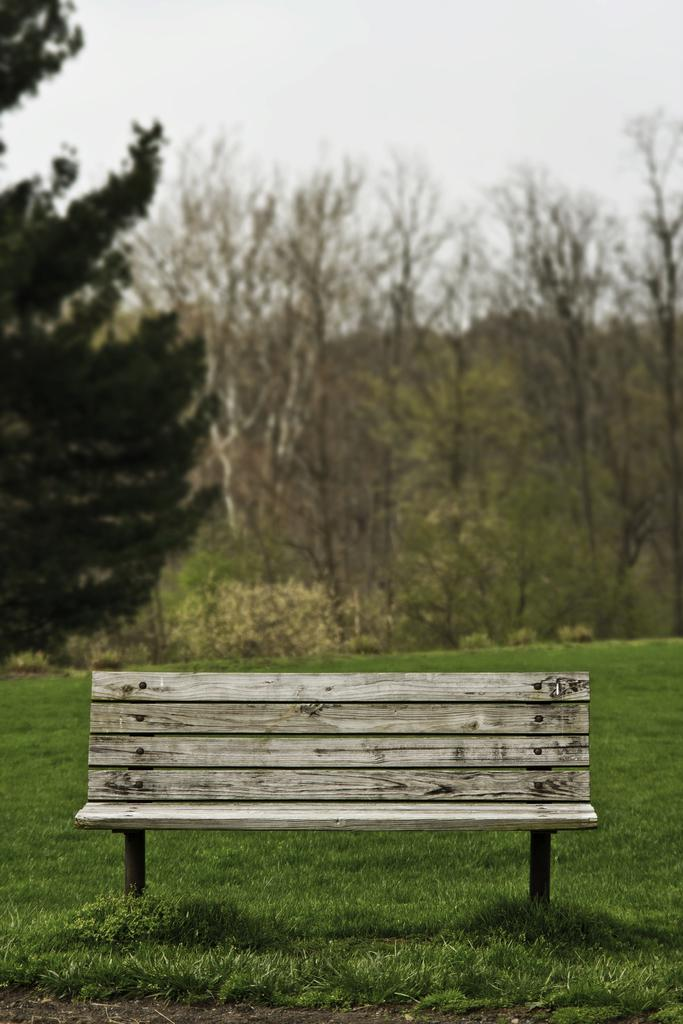What type of seating is present in the image? There is a wooden bench in the image. Where is the bench located? The bench is on grassland. What can be seen behind the bench? There are trees behind the bench. What is visible above the bench? The sky is visible above the bench. What type of stew is being served on the bench in the image? There is no stew present in the image; it features a wooden bench on grassland with trees behind it and the sky visible above. 